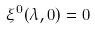<formula> <loc_0><loc_0><loc_500><loc_500>\xi ^ { 0 } ( \lambda , { 0 } ) = 0</formula> 